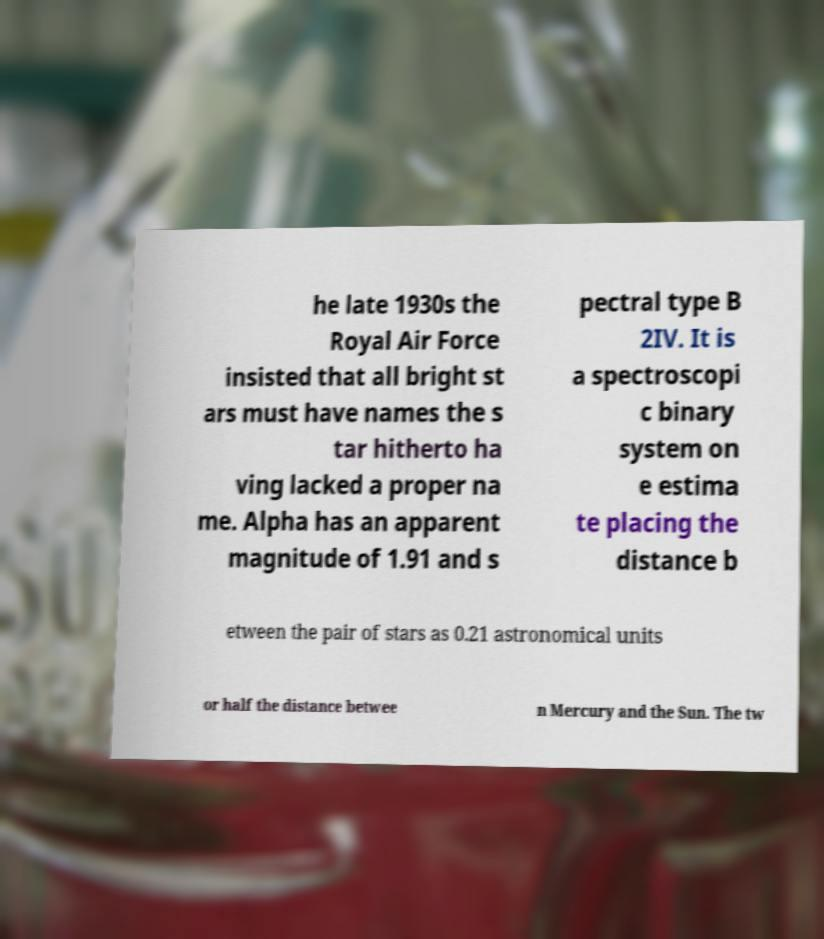Please identify and transcribe the text found in this image. he late 1930s the Royal Air Force insisted that all bright st ars must have names the s tar hitherto ha ving lacked a proper na me. Alpha has an apparent magnitude of 1.91 and s pectral type B 2IV. It is a spectroscopi c binary system on e estima te placing the distance b etween the pair of stars as 0.21 astronomical units or half the distance betwee n Mercury and the Sun. The tw 